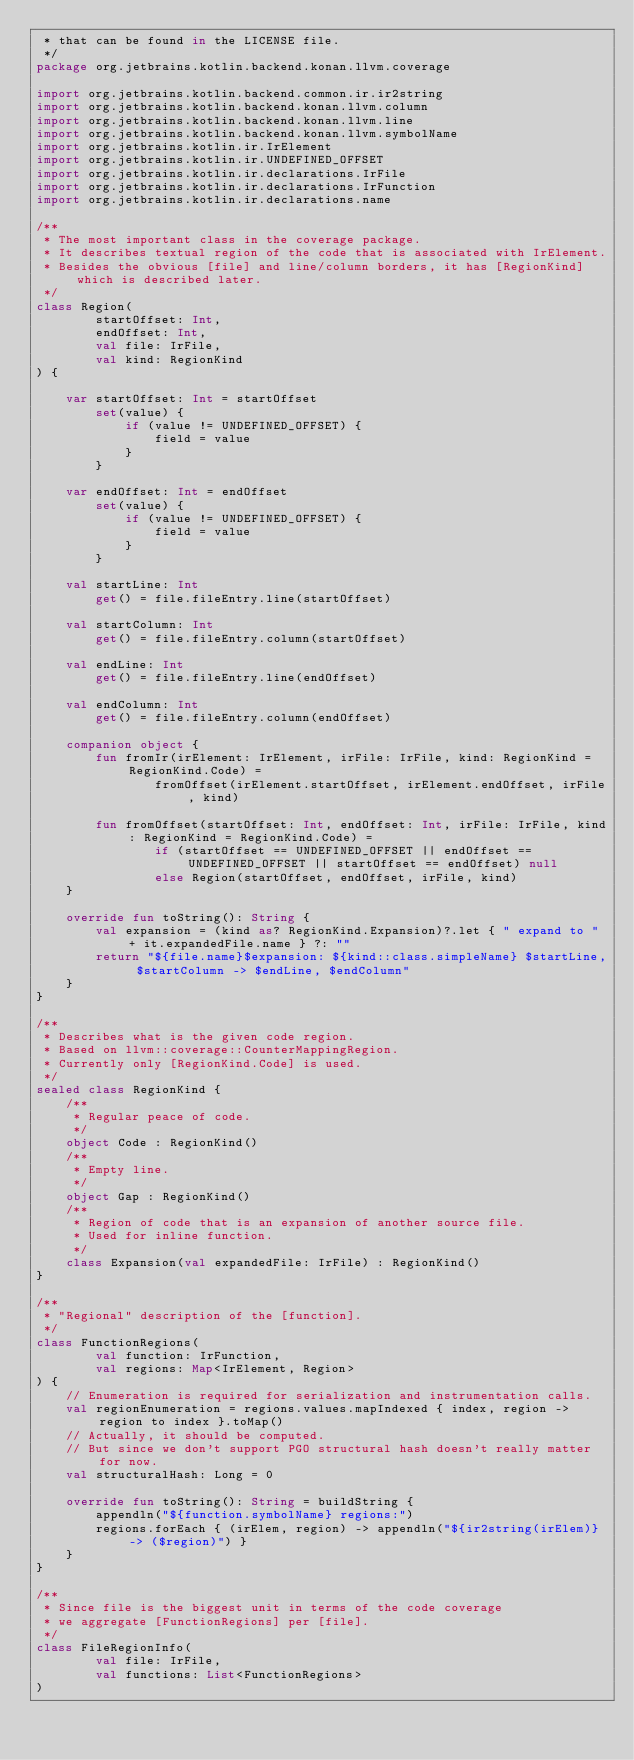Convert code to text. <code><loc_0><loc_0><loc_500><loc_500><_Kotlin_> * that can be found in the LICENSE file.
 */
package org.jetbrains.kotlin.backend.konan.llvm.coverage

import org.jetbrains.kotlin.backend.common.ir.ir2string
import org.jetbrains.kotlin.backend.konan.llvm.column
import org.jetbrains.kotlin.backend.konan.llvm.line
import org.jetbrains.kotlin.backend.konan.llvm.symbolName
import org.jetbrains.kotlin.ir.IrElement
import org.jetbrains.kotlin.ir.UNDEFINED_OFFSET
import org.jetbrains.kotlin.ir.declarations.IrFile
import org.jetbrains.kotlin.ir.declarations.IrFunction
import org.jetbrains.kotlin.ir.declarations.name

/**
 * The most important class in the coverage package.
 * It describes textual region of the code that is associated with IrElement.
 * Besides the obvious [file] and line/column borders, it has [RegionKind] which is described later.
 */
class Region(
        startOffset: Int,
        endOffset: Int,
        val file: IrFile,
        val kind: RegionKind
) {

    var startOffset: Int = startOffset
        set(value) {
            if (value != UNDEFINED_OFFSET) {
                field = value
            }
        }

    var endOffset: Int = endOffset
        set(value) {
            if (value != UNDEFINED_OFFSET) {
                field = value
            }
        }

    val startLine: Int
        get() = file.fileEntry.line(startOffset)

    val startColumn: Int
        get() = file.fileEntry.column(startOffset)

    val endLine: Int
        get() = file.fileEntry.line(endOffset)

    val endColumn: Int
        get() = file.fileEntry.column(endOffset)

    companion object {
        fun fromIr(irElement: IrElement, irFile: IrFile, kind: RegionKind = RegionKind.Code) =
                fromOffset(irElement.startOffset, irElement.endOffset, irFile, kind)

        fun fromOffset(startOffset: Int, endOffset: Int, irFile: IrFile, kind: RegionKind = RegionKind.Code) =
                if (startOffset == UNDEFINED_OFFSET || endOffset == UNDEFINED_OFFSET || startOffset == endOffset) null
                else Region(startOffset, endOffset, irFile, kind)
    }

    override fun toString(): String {
        val expansion = (kind as? RegionKind.Expansion)?.let { " expand to " + it.expandedFile.name } ?: ""
        return "${file.name}$expansion: ${kind::class.simpleName} $startLine, $startColumn -> $endLine, $endColumn"
    }
}

/**
 * Describes what is the given code region.
 * Based on llvm::coverage::CounterMappingRegion.
 * Currently only [RegionKind.Code] is used.
 */
sealed class RegionKind {
    /**
     * Regular peace of code.
     */
    object Code : RegionKind()
    /**
     * Empty line.
     */
    object Gap : RegionKind()
    /**
     * Region of code that is an expansion of another source file.
     * Used for inline function.
     */
    class Expansion(val expandedFile: IrFile) : RegionKind()
}

/**
 * "Regional" description of the [function].
 */
class FunctionRegions(
        val function: IrFunction,
        val regions: Map<IrElement, Region>
) {
    // Enumeration is required for serialization and instrumentation calls.
    val regionEnumeration = regions.values.mapIndexed { index, region -> region to index }.toMap()
    // Actually, it should be computed.
    // But since we don't support PGO structural hash doesn't really matter for now.
    val structuralHash: Long = 0

    override fun toString(): String = buildString {
        appendln("${function.symbolName} regions:")
        regions.forEach { (irElem, region) -> appendln("${ir2string(irElem)} -> ($region)") }
    }
}

/**
 * Since file is the biggest unit in terms of the code coverage
 * we aggregate [FunctionRegions] per [file].
 */
class FileRegionInfo(
        val file: IrFile,
        val functions: List<FunctionRegions>
)</code> 